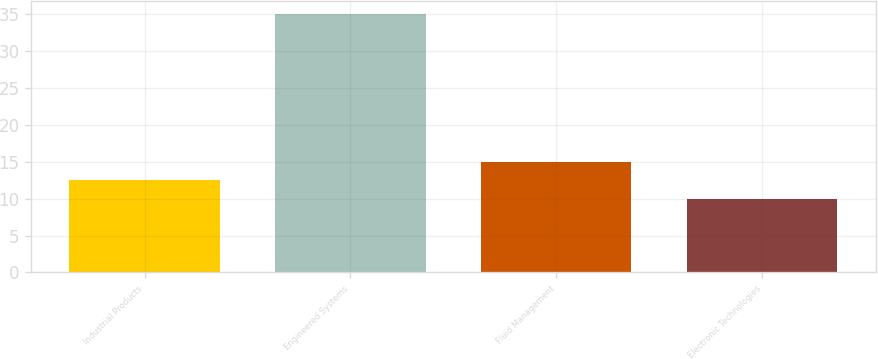Convert chart to OTSL. <chart><loc_0><loc_0><loc_500><loc_500><bar_chart><fcel>Industrial Products<fcel>Engineered Systems<fcel>Fluid Management<fcel>Electronic Technologies<nl><fcel>12.5<fcel>35<fcel>15<fcel>10<nl></chart> 